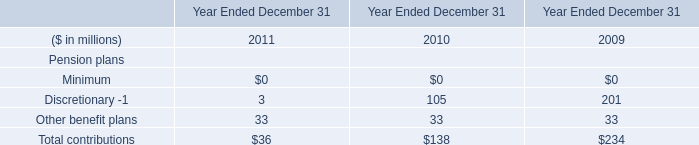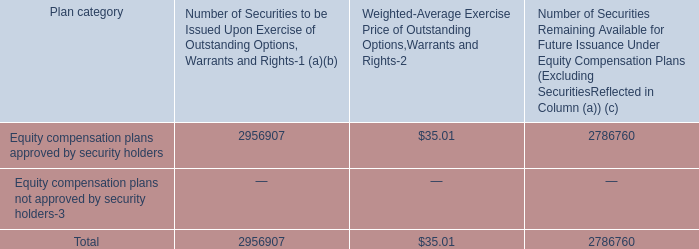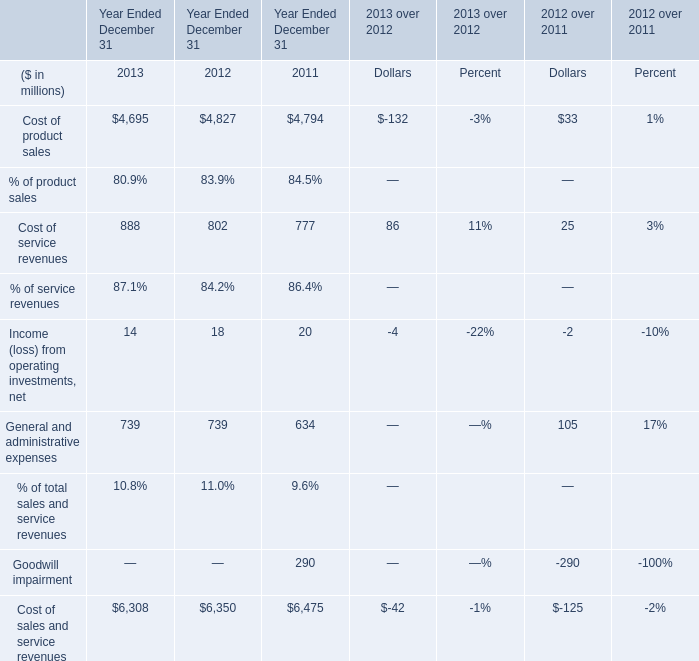What was the total amount of Cost of product sales, Cost of service revenues, Income (loss) from operating investments, net and General and administrative expenses in 2013? (in million) 
Computations: (((4695 + 888) + 14) + 739)
Answer: 6336.0. 